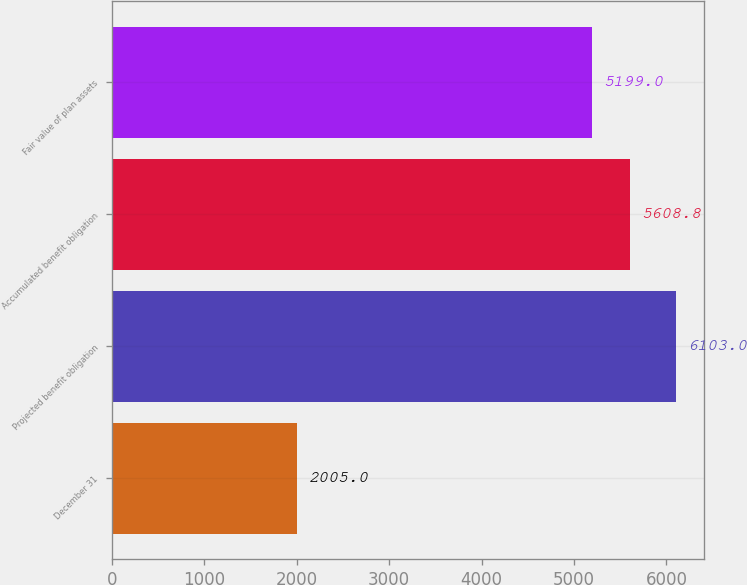Convert chart to OTSL. <chart><loc_0><loc_0><loc_500><loc_500><bar_chart><fcel>December 31<fcel>Projected benefit obligation<fcel>Accumulated benefit obligation<fcel>Fair value of plan assets<nl><fcel>2005<fcel>6103<fcel>5608.8<fcel>5199<nl></chart> 